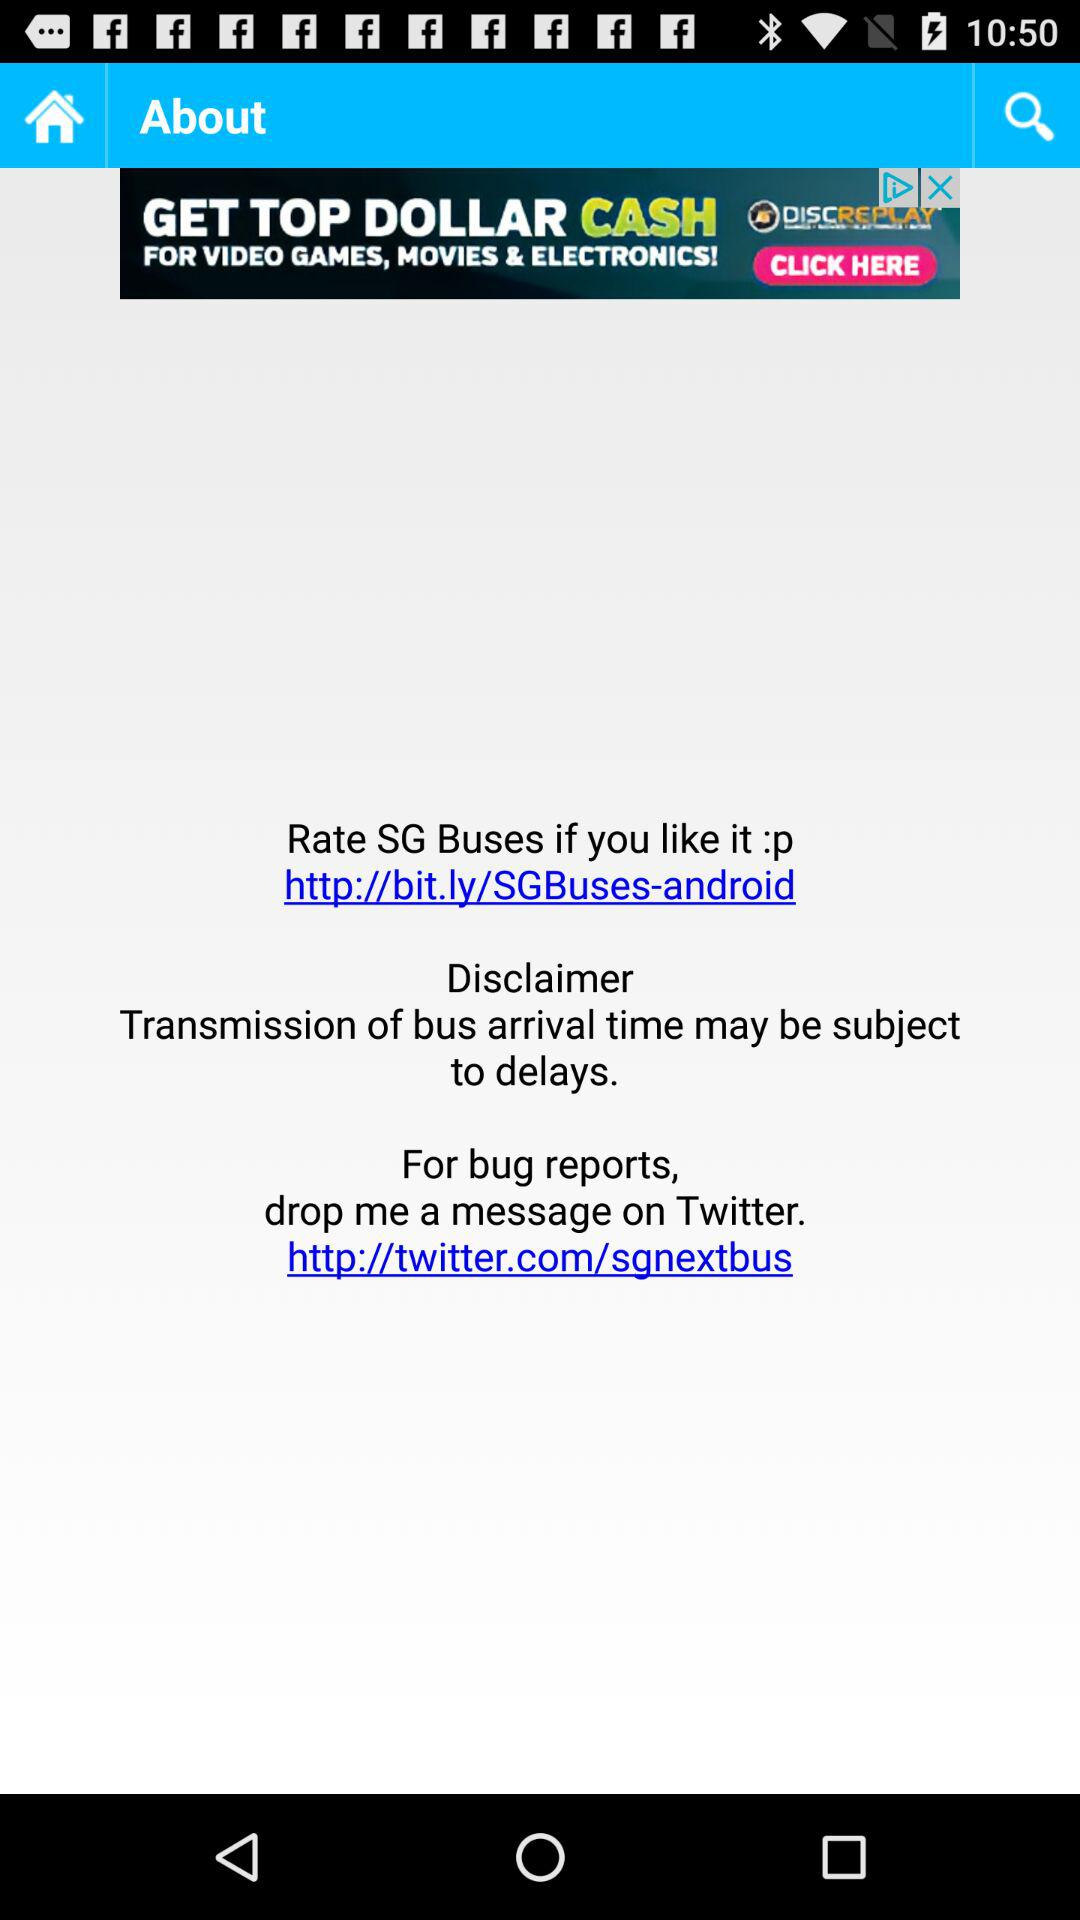What's the hyperlink address for rating the application? The hyperlink address for rating the application is http://bit.ly/SGBuses-android. 